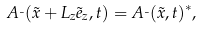Convert formula to latex. <formula><loc_0><loc_0><loc_500><loc_500>A _ { \mu } ( \vec { x } + L _ { z } \vec { e } _ { z } , t ) = A _ { \mu } ( \vec { x } , t ) ^ { * } ,</formula> 